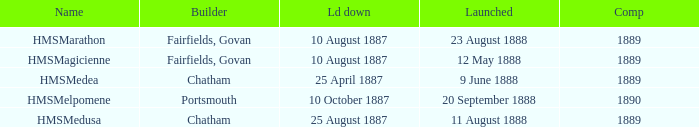When did chatham complete the Hmsmedusa? 1889.0. Can you parse all the data within this table? {'header': ['Name', 'Builder', 'Ld down', 'Launched', 'Comp'], 'rows': [['HMSMarathon', 'Fairfields, Govan', '10 August 1887', '23 August 1888', '1889'], ['HMSMagicienne', 'Fairfields, Govan', '10 August 1887', '12 May 1888', '1889'], ['HMSMedea', 'Chatham', '25 April 1887', '9 June 1888', '1889'], ['HMSMelpomene', 'Portsmouth', '10 October 1887', '20 September 1888', '1890'], ['HMSMedusa', 'Chatham', '25 August 1887', '11 August 1888', '1889']]} 